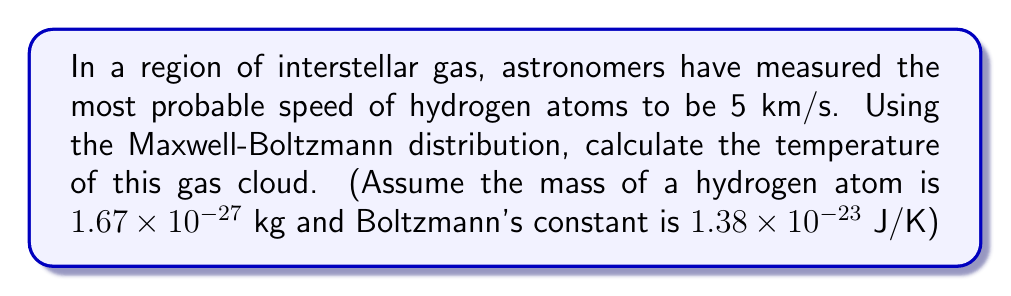Solve this math problem. To solve this problem, we'll use the Maxwell-Boltzmann distribution and follow these steps:

1) The most probable speed in the Maxwell-Boltzmann distribution is given by:

   $$v_p = \sqrt{\frac{2kT}{m}}$$

   Where $v_p$ is the most probable speed, $k$ is Boltzmann's constant, $T$ is temperature, and $m$ is the mass of the particle.

2) We're given:
   $v_p = 5$ km/s = $5000$ m/s
   $m = 1.67 \times 10^{-27}$ kg
   $k = 1.38 \times 10^{-23}$ J/K

3) Let's rearrange the equation to solve for T:

   $$T = \frac{mv_p^2}{2k}$$

4) Now, let's substitute our values:

   $$T = \frac{(1.67 \times 10^{-27} \text{ kg})(5000 \text{ m/s})^2}{2(1.38 \times 10^{-23} \text{ J/K})}$$

5) Calculate:

   $$T = \frac{4.175 \times 10^{-18}}{2.76 \times 10^{-23}} = 1.51 \times 10^5 \text{ K}$$

6) Round to three significant figures:

   $$T \approx 1.51 \times 10^5 \text{ K}$$
Answer: $1.51 \times 10^5$ K 